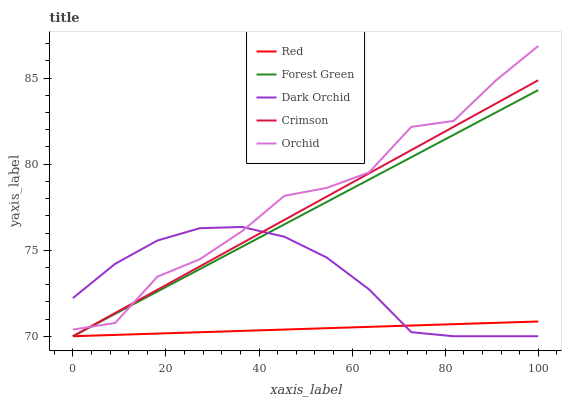Does Red have the minimum area under the curve?
Answer yes or no. Yes. Does Orchid have the maximum area under the curve?
Answer yes or no. Yes. Does Forest Green have the minimum area under the curve?
Answer yes or no. No. Does Forest Green have the maximum area under the curve?
Answer yes or no. No. Is Forest Green the smoothest?
Answer yes or no. Yes. Is Orchid the roughest?
Answer yes or no. Yes. Is Dark Orchid the smoothest?
Answer yes or no. No. Is Dark Orchid the roughest?
Answer yes or no. No. Does Crimson have the lowest value?
Answer yes or no. Yes. Does Orchid have the lowest value?
Answer yes or no. No. Does Orchid have the highest value?
Answer yes or no. Yes. Does Forest Green have the highest value?
Answer yes or no. No. Is Red less than Orchid?
Answer yes or no. Yes. Is Orchid greater than Red?
Answer yes or no. Yes. Does Forest Green intersect Orchid?
Answer yes or no. Yes. Is Forest Green less than Orchid?
Answer yes or no. No. Is Forest Green greater than Orchid?
Answer yes or no. No. Does Red intersect Orchid?
Answer yes or no. No. 